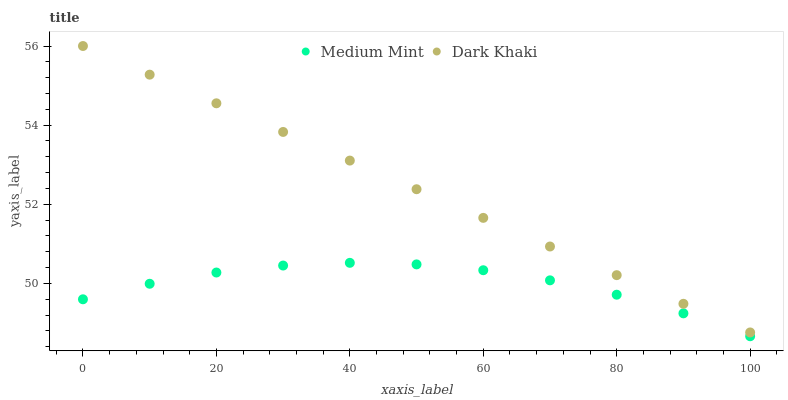Does Medium Mint have the minimum area under the curve?
Answer yes or no. Yes. Does Dark Khaki have the maximum area under the curve?
Answer yes or no. Yes. Does Dark Khaki have the minimum area under the curve?
Answer yes or no. No. Is Dark Khaki the smoothest?
Answer yes or no. Yes. Is Medium Mint the roughest?
Answer yes or no. Yes. Is Dark Khaki the roughest?
Answer yes or no. No. Does Medium Mint have the lowest value?
Answer yes or no. Yes. Does Dark Khaki have the lowest value?
Answer yes or no. No. Does Dark Khaki have the highest value?
Answer yes or no. Yes. Is Medium Mint less than Dark Khaki?
Answer yes or no. Yes. Is Dark Khaki greater than Medium Mint?
Answer yes or no. Yes. Does Medium Mint intersect Dark Khaki?
Answer yes or no. No. 